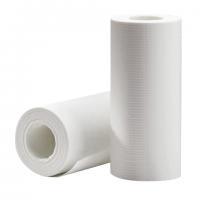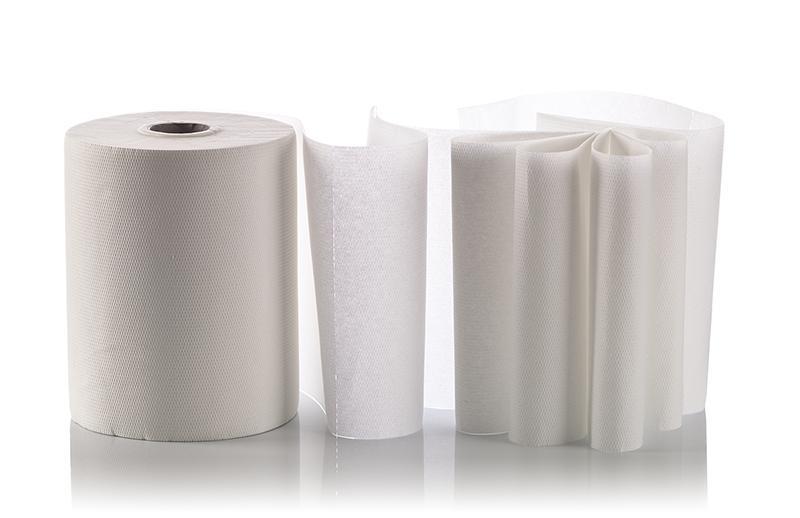The first image is the image on the left, the second image is the image on the right. Considering the images on both sides, is "Both images show white paper towels on rolls." valid? Answer yes or no. Yes. 